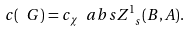Convert formula to latex. <formula><loc_0><loc_0><loc_500><loc_500>c ( \ G ) = c _ { \chi } \ a b s { Z ^ { 1 } _ { \ s } ( B , A ) } .</formula> 